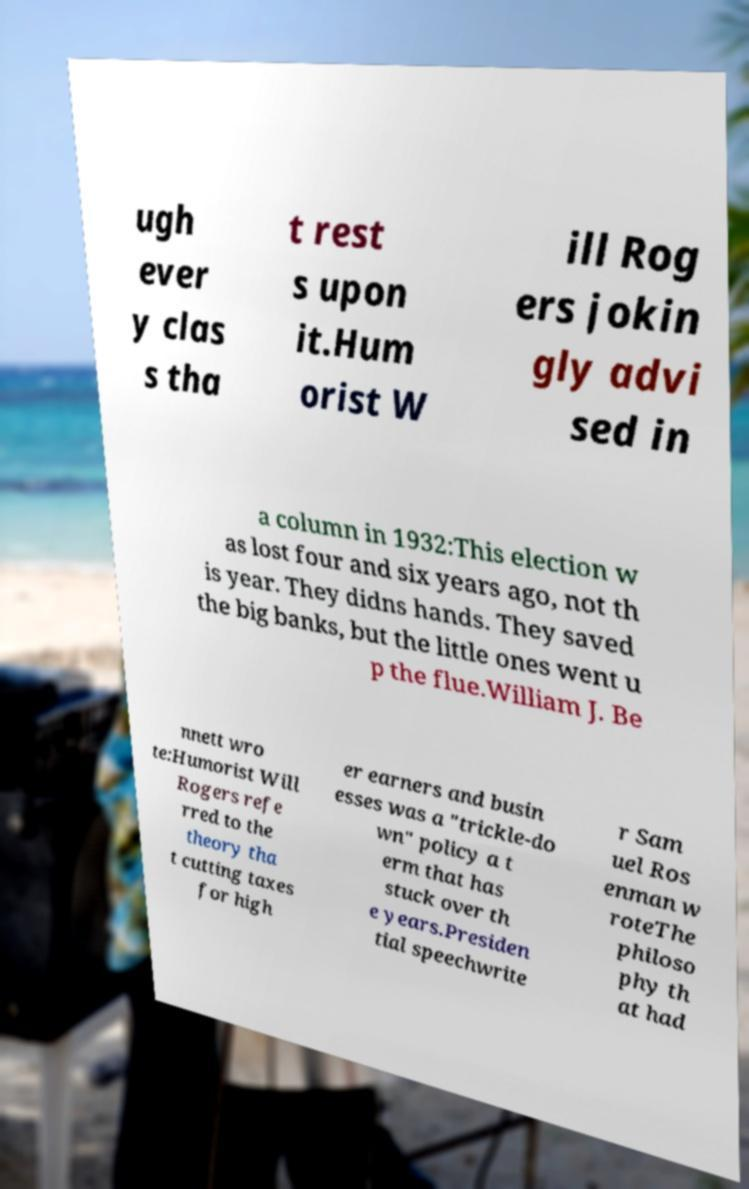What messages or text are displayed in this image? I need them in a readable, typed format. ugh ever y clas s tha t rest s upon it.Hum orist W ill Rog ers jokin gly advi sed in a column in 1932:This election w as lost four and six years ago, not th is year. They didns hands. They saved the big banks, but the little ones went u p the flue.William J. Be nnett wro te:Humorist Will Rogers refe rred to the theory tha t cutting taxes for high er earners and busin esses was a "trickle-do wn" policy a t erm that has stuck over th e years.Presiden tial speechwrite r Sam uel Ros enman w roteThe philoso phy th at had 